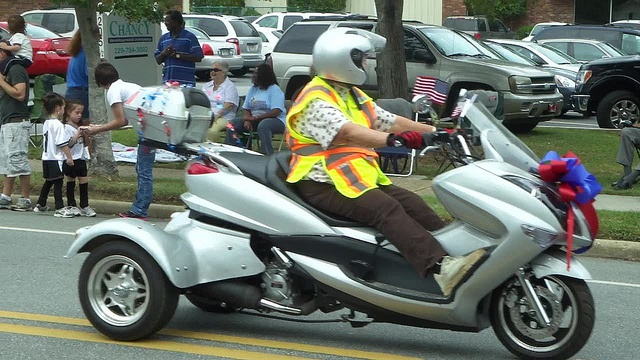Describe the objects in this image and their specific colors. I can see motorcycle in black, gray, white, and darkgray tones, people in black, white, darkgray, and gray tones, car in black, gray, lightgray, and darkgray tones, car in black, gray, and darkgray tones, and people in black, darkgray, gray, and maroon tones in this image. 